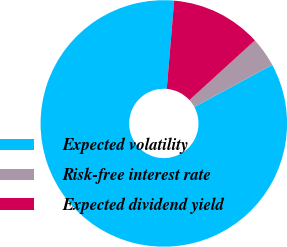<chart> <loc_0><loc_0><loc_500><loc_500><pie_chart><fcel>Expected volatility<fcel>Risk-free interest rate<fcel>Expected dividend yield<nl><fcel>84.23%<fcel>3.87%<fcel>11.9%<nl></chart> 